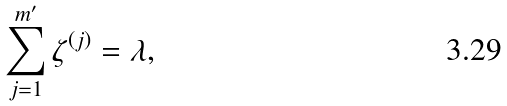Convert formula to latex. <formula><loc_0><loc_0><loc_500><loc_500>\sum _ { j = 1 } ^ { m ^ { \prime } } \zeta ^ { \left ( j \right ) } = \lambda ,</formula> 